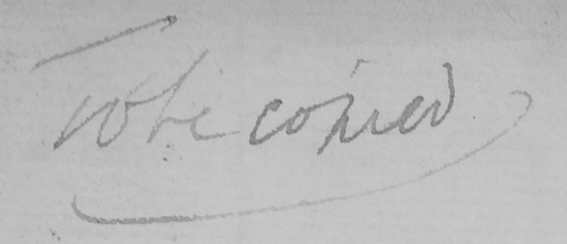Can you read and transcribe this handwriting? To be copied 